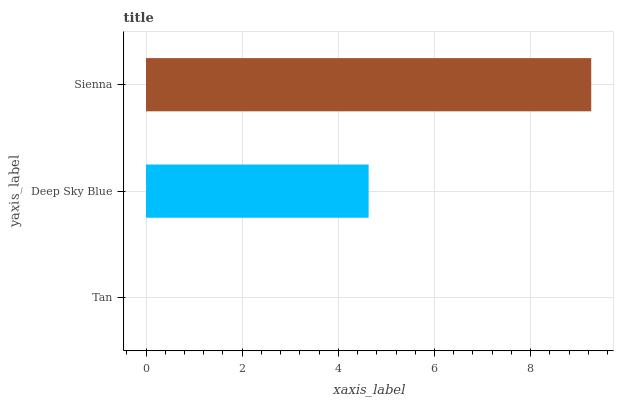Is Tan the minimum?
Answer yes or no. Yes. Is Sienna the maximum?
Answer yes or no. Yes. Is Deep Sky Blue the minimum?
Answer yes or no. No. Is Deep Sky Blue the maximum?
Answer yes or no. No. Is Deep Sky Blue greater than Tan?
Answer yes or no. Yes. Is Tan less than Deep Sky Blue?
Answer yes or no. Yes. Is Tan greater than Deep Sky Blue?
Answer yes or no. No. Is Deep Sky Blue less than Tan?
Answer yes or no. No. Is Deep Sky Blue the high median?
Answer yes or no. Yes. Is Deep Sky Blue the low median?
Answer yes or no. Yes. Is Sienna the high median?
Answer yes or no. No. Is Sienna the low median?
Answer yes or no. No. 